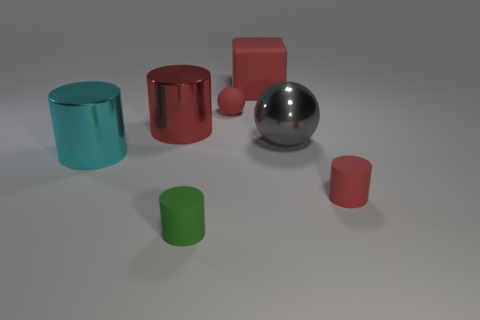How many red cylinders must be subtracted to get 1 red cylinders? 1 Subtract all cyan cylinders. How many cylinders are left? 3 Subtract 0 brown cubes. How many objects are left? 7 Subtract all spheres. How many objects are left? 5 Subtract 1 blocks. How many blocks are left? 0 Subtract all yellow cylinders. Subtract all brown spheres. How many cylinders are left? 4 Subtract all cyan blocks. How many red cylinders are left? 2 Subtract all big yellow rubber cylinders. Subtract all metallic objects. How many objects are left? 4 Add 4 big cylinders. How many big cylinders are left? 6 Add 6 large gray rubber things. How many large gray rubber things exist? 6 